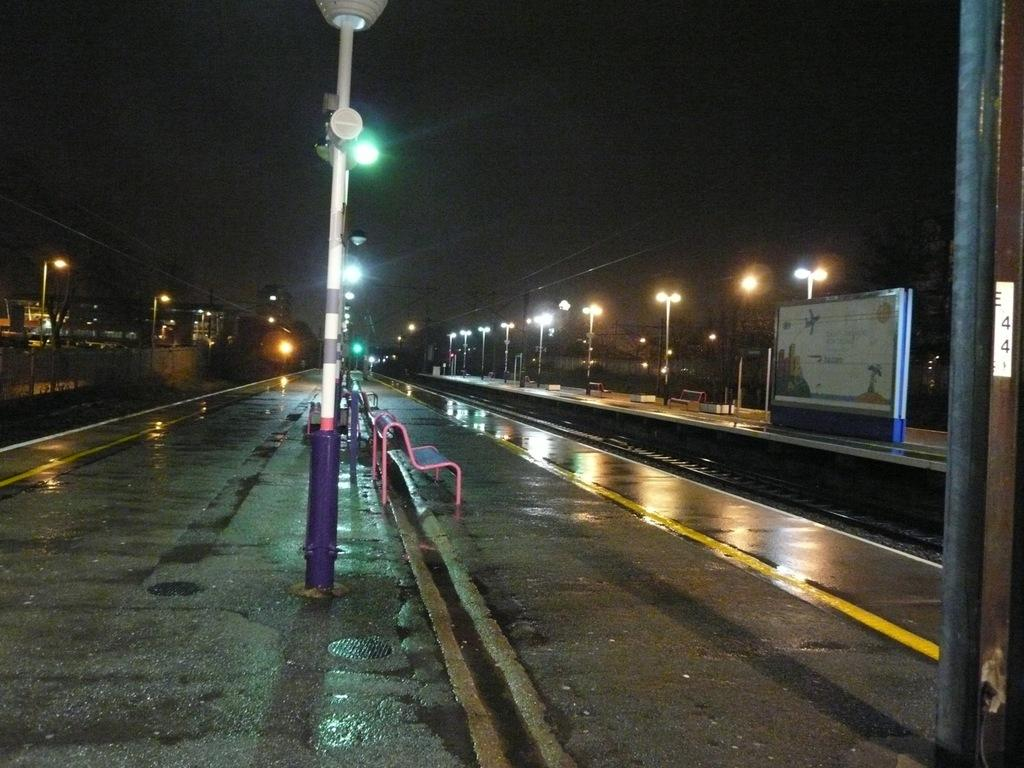What type of objects are on the ground in the image? There are benches and street lights on the ground in the image. What can be seen in the image besides the objects on the ground? There is a board, a railway track, and a fence in the image. What is visible in the sky in the image? The sky is visible in the image. What songs are being played on the calendar in the image? There is no calendar present in the image, and therefore no songs can be associated with it. 